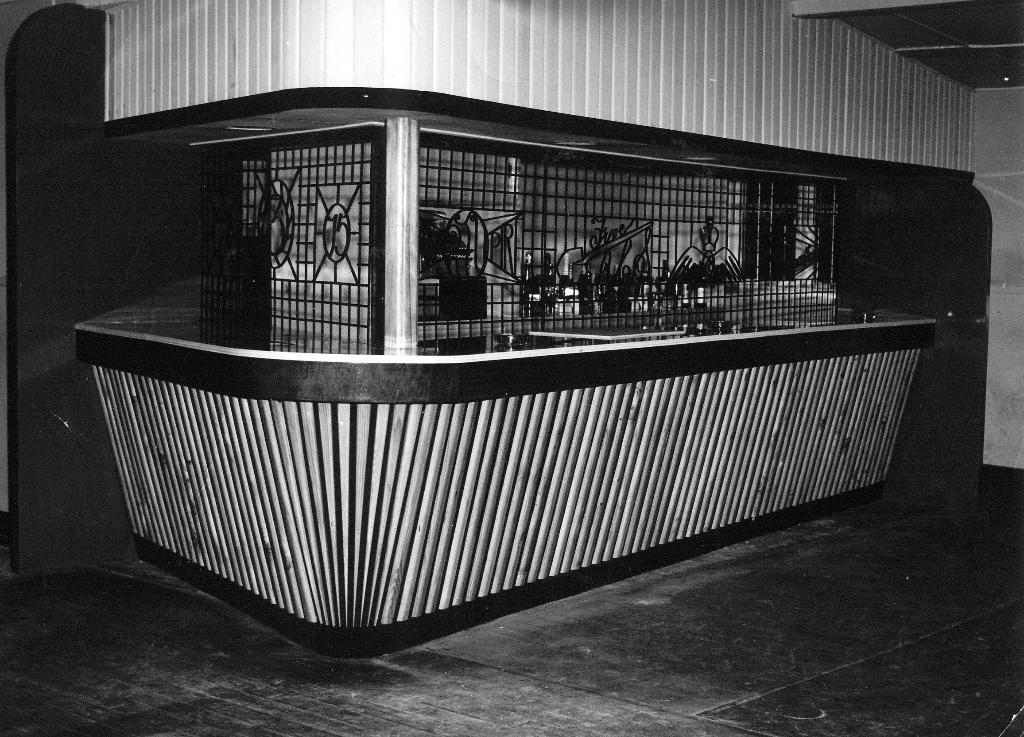How would you summarize this image in a sentence or two? This is a black and white image. Here I can see a construction. At the bottom there is a railing. In the middle there is a metal frame which is looking like a cabin. Inside there are few objects. At the top of the image I can see the wall. At the bottom of the image I can see the floor. 